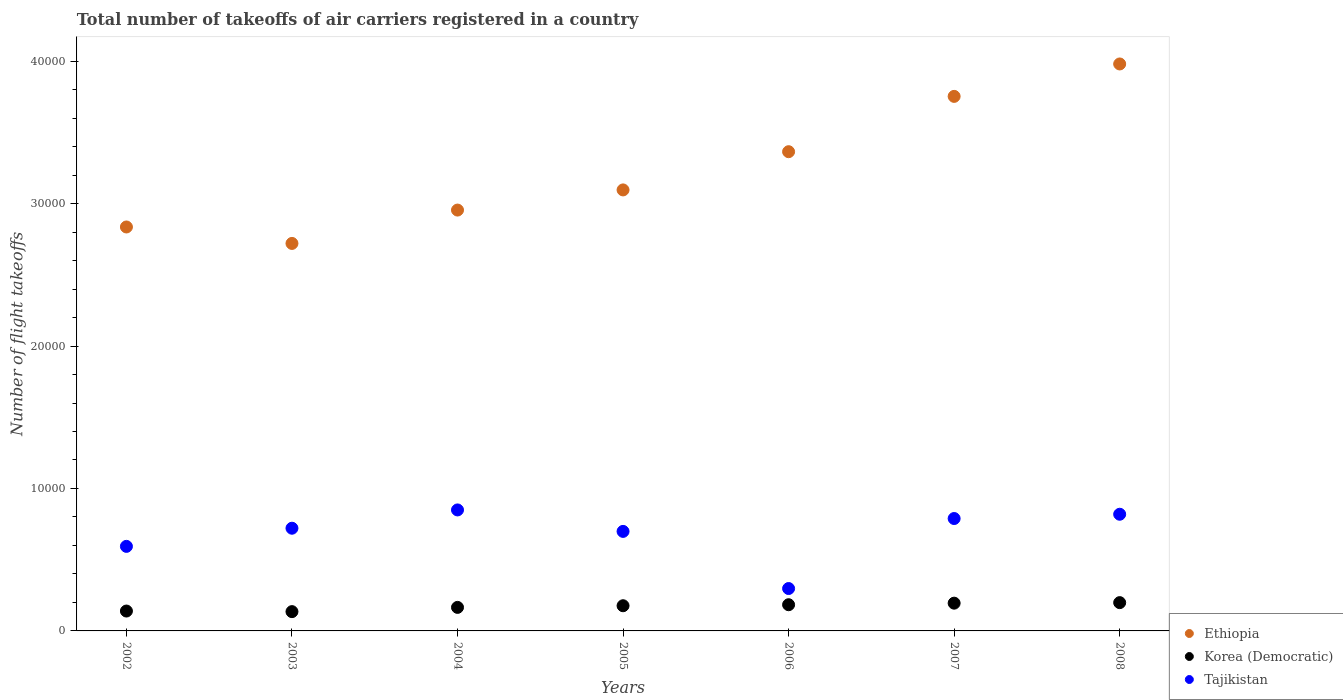How many different coloured dotlines are there?
Ensure brevity in your answer.  3. What is the total number of flight takeoffs in Korea (Democratic) in 2005?
Offer a very short reply. 1768. Across all years, what is the maximum total number of flight takeoffs in Korea (Democratic)?
Make the answer very short. 1986. Across all years, what is the minimum total number of flight takeoffs in Korea (Democratic)?
Provide a short and direct response. 1354. What is the total total number of flight takeoffs in Korea (Democratic) in the graph?
Ensure brevity in your answer.  1.19e+04. What is the difference between the total number of flight takeoffs in Ethiopia in 2002 and that in 2003?
Provide a succinct answer. 1155. What is the difference between the total number of flight takeoffs in Korea (Democratic) in 2004 and the total number of flight takeoffs in Tajikistan in 2007?
Offer a terse response. -6239. What is the average total number of flight takeoffs in Tajikistan per year?
Your response must be concise. 6812.14. In the year 2004, what is the difference between the total number of flight takeoffs in Tajikistan and total number of flight takeoffs in Korea (Democratic)?
Keep it short and to the point. 6842. In how many years, is the total number of flight takeoffs in Korea (Democratic) greater than 20000?
Your answer should be very brief. 0. What is the ratio of the total number of flight takeoffs in Korea (Democratic) in 2002 to that in 2005?
Provide a short and direct response. 0.79. Is the total number of flight takeoffs in Ethiopia in 2002 less than that in 2005?
Your answer should be very brief. Yes. What is the difference between the highest and the second highest total number of flight takeoffs in Tajikistan?
Your answer should be compact. 303. What is the difference between the highest and the lowest total number of flight takeoffs in Korea (Democratic)?
Make the answer very short. 632. Is the sum of the total number of flight takeoffs in Korea (Democratic) in 2006 and 2007 greater than the maximum total number of flight takeoffs in Tajikistan across all years?
Offer a terse response. No. Is it the case that in every year, the sum of the total number of flight takeoffs in Korea (Democratic) and total number of flight takeoffs in Tajikistan  is greater than the total number of flight takeoffs in Ethiopia?
Keep it short and to the point. No. Does the total number of flight takeoffs in Korea (Democratic) monotonically increase over the years?
Make the answer very short. No. Is the total number of flight takeoffs in Ethiopia strictly greater than the total number of flight takeoffs in Tajikistan over the years?
Your answer should be compact. Yes. Is the total number of flight takeoffs in Ethiopia strictly less than the total number of flight takeoffs in Korea (Democratic) over the years?
Provide a short and direct response. No. How many years are there in the graph?
Give a very brief answer. 7. Where does the legend appear in the graph?
Provide a short and direct response. Bottom right. How many legend labels are there?
Offer a terse response. 3. How are the legend labels stacked?
Your answer should be compact. Vertical. What is the title of the graph?
Provide a succinct answer. Total number of takeoffs of air carriers registered in a country. Does "Gabon" appear as one of the legend labels in the graph?
Ensure brevity in your answer.  No. What is the label or title of the Y-axis?
Make the answer very short. Number of flight takeoffs. What is the Number of flight takeoffs of Ethiopia in 2002?
Your response must be concise. 2.84e+04. What is the Number of flight takeoffs in Korea (Democratic) in 2002?
Offer a terse response. 1396. What is the Number of flight takeoffs of Tajikistan in 2002?
Your answer should be compact. 5936. What is the Number of flight takeoffs of Ethiopia in 2003?
Ensure brevity in your answer.  2.72e+04. What is the Number of flight takeoffs in Korea (Democratic) in 2003?
Offer a very short reply. 1354. What is the Number of flight takeoffs in Tajikistan in 2003?
Provide a short and direct response. 7210. What is the Number of flight takeoffs of Ethiopia in 2004?
Your answer should be compact. 2.95e+04. What is the Number of flight takeoffs of Korea (Democratic) in 2004?
Provide a short and direct response. 1652. What is the Number of flight takeoffs of Tajikistan in 2004?
Your response must be concise. 8494. What is the Number of flight takeoffs in Ethiopia in 2005?
Provide a succinct answer. 3.10e+04. What is the Number of flight takeoffs in Korea (Democratic) in 2005?
Offer a terse response. 1768. What is the Number of flight takeoffs of Tajikistan in 2005?
Your answer should be compact. 6987. What is the Number of flight takeoffs in Ethiopia in 2006?
Your answer should be very brief. 3.36e+04. What is the Number of flight takeoffs of Korea (Democratic) in 2006?
Provide a succinct answer. 1839. What is the Number of flight takeoffs of Tajikistan in 2006?
Provide a succinct answer. 2976. What is the Number of flight takeoffs in Ethiopia in 2007?
Make the answer very short. 3.75e+04. What is the Number of flight takeoffs in Korea (Democratic) in 2007?
Keep it short and to the point. 1949. What is the Number of flight takeoffs in Tajikistan in 2007?
Ensure brevity in your answer.  7891. What is the Number of flight takeoffs in Ethiopia in 2008?
Ensure brevity in your answer.  3.98e+04. What is the Number of flight takeoffs in Korea (Democratic) in 2008?
Your answer should be compact. 1986. What is the Number of flight takeoffs in Tajikistan in 2008?
Give a very brief answer. 8191. Across all years, what is the maximum Number of flight takeoffs in Ethiopia?
Offer a very short reply. 3.98e+04. Across all years, what is the maximum Number of flight takeoffs of Korea (Democratic)?
Your response must be concise. 1986. Across all years, what is the maximum Number of flight takeoffs of Tajikistan?
Give a very brief answer. 8494. Across all years, what is the minimum Number of flight takeoffs in Ethiopia?
Your answer should be compact. 2.72e+04. Across all years, what is the minimum Number of flight takeoffs in Korea (Democratic)?
Your answer should be compact. 1354. Across all years, what is the minimum Number of flight takeoffs in Tajikistan?
Your answer should be very brief. 2976. What is the total Number of flight takeoffs in Ethiopia in the graph?
Ensure brevity in your answer.  2.27e+05. What is the total Number of flight takeoffs of Korea (Democratic) in the graph?
Provide a short and direct response. 1.19e+04. What is the total Number of flight takeoffs of Tajikistan in the graph?
Ensure brevity in your answer.  4.77e+04. What is the difference between the Number of flight takeoffs in Ethiopia in 2002 and that in 2003?
Your answer should be very brief. 1155. What is the difference between the Number of flight takeoffs in Korea (Democratic) in 2002 and that in 2003?
Provide a succinct answer. 42. What is the difference between the Number of flight takeoffs in Tajikistan in 2002 and that in 2003?
Offer a very short reply. -1274. What is the difference between the Number of flight takeoffs in Ethiopia in 2002 and that in 2004?
Give a very brief answer. -1187. What is the difference between the Number of flight takeoffs of Korea (Democratic) in 2002 and that in 2004?
Provide a succinct answer. -256. What is the difference between the Number of flight takeoffs in Tajikistan in 2002 and that in 2004?
Your answer should be compact. -2558. What is the difference between the Number of flight takeoffs in Ethiopia in 2002 and that in 2005?
Your answer should be compact. -2602. What is the difference between the Number of flight takeoffs of Korea (Democratic) in 2002 and that in 2005?
Ensure brevity in your answer.  -372. What is the difference between the Number of flight takeoffs of Tajikistan in 2002 and that in 2005?
Make the answer very short. -1051. What is the difference between the Number of flight takeoffs of Ethiopia in 2002 and that in 2006?
Offer a terse response. -5285. What is the difference between the Number of flight takeoffs in Korea (Democratic) in 2002 and that in 2006?
Provide a short and direct response. -443. What is the difference between the Number of flight takeoffs in Tajikistan in 2002 and that in 2006?
Provide a succinct answer. 2960. What is the difference between the Number of flight takeoffs in Ethiopia in 2002 and that in 2007?
Offer a terse response. -9169. What is the difference between the Number of flight takeoffs of Korea (Democratic) in 2002 and that in 2007?
Keep it short and to the point. -553. What is the difference between the Number of flight takeoffs in Tajikistan in 2002 and that in 2007?
Keep it short and to the point. -1955. What is the difference between the Number of flight takeoffs in Ethiopia in 2002 and that in 2008?
Your answer should be very brief. -1.14e+04. What is the difference between the Number of flight takeoffs of Korea (Democratic) in 2002 and that in 2008?
Your answer should be compact. -590. What is the difference between the Number of flight takeoffs of Tajikistan in 2002 and that in 2008?
Ensure brevity in your answer.  -2255. What is the difference between the Number of flight takeoffs in Ethiopia in 2003 and that in 2004?
Give a very brief answer. -2342. What is the difference between the Number of flight takeoffs of Korea (Democratic) in 2003 and that in 2004?
Provide a short and direct response. -298. What is the difference between the Number of flight takeoffs of Tajikistan in 2003 and that in 2004?
Give a very brief answer. -1284. What is the difference between the Number of flight takeoffs of Ethiopia in 2003 and that in 2005?
Offer a very short reply. -3757. What is the difference between the Number of flight takeoffs in Korea (Democratic) in 2003 and that in 2005?
Your answer should be very brief. -414. What is the difference between the Number of flight takeoffs in Tajikistan in 2003 and that in 2005?
Give a very brief answer. 223. What is the difference between the Number of flight takeoffs of Ethiopia in 2003 and that in 2006?
Offer a terse response. -6440. What is the difference between the Number of flight takeoffs of Korea (Democratic) in 2003 and that in 2006?
Offer a terse response. -485. What is the difference between the Number of flight takeoffs in Tajikistan in 2003 and that in 2006?
Provide a short and direct response. 4234. What is the difference between the Number of flight takeoffs of Ethiopia in 2003 and that in 2007?
Provide a short and direct response. -1.03e+04. What is the difference between the Number of flight takeoffs in Korea (Democratic) in 2003 and that in 2007?
Your answer should be compact. -595. What is the difference between the Number of flight takeoffs in Tajikistan in 2003 and that in 2007?
Provide a succinct answer. -681. What is the difference between the Number of flight takeoffs of Ethiopia in 2003 and that in 2008?
Your answer should be compact. -1.26e+04. What is the difference between the Number of flight takeoffs in Korea (Democratic) in 2003 and that in 2008?
Give a very brief answer. -632. What is the difference between the Number of flight takeoffs in Tajikistan in 2003 and that in 2008?
Provide a short and direct response. -981. What is the difference between the Number of flight takeoffs in Ethiopia in 2004 and that in 2005?
Your answer should be very brief. -1415. What is the difference between the Number of flight takeoffs in Korea (Democratic) in 2004 and that in 2005?
Provide a succinct answer. -116. What is the difference between the Number of flight takeoffs in Tajikistan in 2004 and that in 2005?
Give a very brief answer. 1507. What is the difference between the Number of flight takeoffs of Ethiopia in 2004 and that in 2006?
Give a very brief answer. -4098. What is the difference between the Number of flight takeoffs of Korea (Democratic) in 2004 and that in 2006?
Your response must be concise. -187. What is the difference between the Number of flight takeoffs in Tajikistan in 2004 and that in 2006?
Ensure brevity in your answer.  5518. What is the difference between the Number of flight takeoffs in Ethiopia in 2004 and that in 2007?
Provide a short and direct response. -7982. What is the difference between the Number of flight takeoffs in Korea (Democratic) in 2004 and that in 2007?
Your answer should be compact. -297. What is the difference between the Number of flight takeoffs in Tajikistan in 2004 and that in 2007?
Make the answer very short. 603. What is the difference between the Number of flight takeoffs in Ethiopia in 2004 and that in 2008?
Your answer should be very brief. -1.03e+04. What is the difference between the Number of flight takeoffs in Korea (Democratic) in 2004 and that in 2008?
Offer a very short reply. -334. What is the difference between the Number of flight takeoffs in Tajikistan in 2004 and that in 2008?
Your answer should be very brief. 303. What is the difference between the Number of flight takeoffs in Ethiopia in 2005 and that in 2006?
Make the answer very short. -2683. What is the difference between the Number of flight takeoffs in Korea (Democratic) in 2005 and that in 2006?
Keep it short and to the point. -71. What is the difference between the Number of flight takeoffs in Tajikistan in 2005 and that in 2006?
Provide a short and direct response. 4011. What is the difference between the Number of flight takeoffs in Ethiopia in 2005 and that in 2007?
Offer a terse response. -6567. What is the difference between the Number of flight takeoffs of Korea (Democratic) in 2005 and that in 2007?
Make the answer very short. -181. What is the difference between the Number of flight takeoffs of Tajikistan in 2005 and that in 2007?
Keep it short and to the point. -904. What is the difference between the Number of flight takeoffs in Ethiopia in 2005 and that in 2008?
Offer a terse response. -8843. What is the difference between the Number of flight takeoffs in Korea (Democratic) in 2005 and that in 2008?
Your answer should be compact. -218. What is the difference between the Number of flight takeoffs in Tajikistan in 2005 and that in 2008?
Ensure brevity in your answer.  -1204. What is the difference between the Number of flight takeoffs of Ethiopia in 2006 and that in 2007?
Offer a terse response. -3884. What is the difference between the Number of flight takeoffs of Korea (Democratic) in 2006 and that in 2007?
Your answer should be very brief. -110. What is the difference between the Number of flight takeoffs of Tajikistan in 2006 and that in 2007?
Keep it short and to the point. -4915. What is the difference between the Number of flight takeoffs of Ethiopia in 2006 and that in 2008?
Your answer should be compact. -6160. What is the difference between the Number of flight takeoffs of Korea (Democratic) in 2006 and that in 2008?
Provide a short and direct response. -147. What is the difference between the Number of flight takeoffs of Tajikistan in 2006 and that in 2008?
Keep it short and to the point. -5215. What is the difference between the Number of flight takeoffs of Ethiopia in 2007 and that in 2008?
Your answer should be compact. -2276. What is the difference between the Number of flight takeoffs of Korea (Democratic) in 2007 and that in 2008?
Offer a very short reply. -37. What is the difference between the Number of flight takeoffs of Tajikistan in 2007 and that in 2008?
Your answer should be very brief. -300. What is the difference between the Number of flight takeoffs of Ethiopia in 2002 and the Number of flight takeoffs of Korea (Democratic) in 2003?
Your answer should be compact. 2.70e+04. What is the difference between the Number of flight takeoffs in Ethiopia in 2002 and the Number of flight takeoffs in Tajikistan in 2003?
Offer a very short reply. 2.11e+04. What is the difference between the Number of flight takeoffs of Korea (Democratic) in 2002 and the Number of flight takeoffs of Tajikistan in 2003?
Provide a succinct answer. -5814. What is the difference between the Number of flight takeoffs of Ethiopia in 2002 and the Number of flight takeoffs of Korea (Democratic) in 2004?
Provide a succinct answer. 2.67e+04. What is the difference between the Number of flight takeoffs in Ethiopia in 2002 and the Number of flight takeoffs in Tajikistan in 2004?
Your answer should be very brief. 1.99e+04. What is the difference between the Number of flight takeoffs in Korea (Democratic) in 2002 and the Number of flight takeoffs in Tajikistan in 2004?
Your answer should be very brief. -7098. What is the difference between the Number of flight takeoffs in Ethiopia in 2002 and the Number of flight takeoffs in Korea (Democratic) in 2005?
Offer a very short reply. 2.66e+04. What is the difference between the Number of flight takeoffs in Ethiopia in 2002 and the Number of flight takeoffs in Tajikistan in 2005?
Give a very brief answer. 2.14e+04. What is the difference between the Number of flight takeoffs of Korea (Democratic) in 2002 and the Number of flight takeoffs of Tajikistan in 2005?
Your response must be concise. -5591. What is the difference between the Number of flight takeoffs of Ethiopia in 2002 and the Number of flight takeoffs of Korea (Democratic) in 2006?
Your answer should be very brief. 2.65e+04. What is the difference between the Number of flight takeoffs of Ethiopia in 2002 and the Number of flight takeoffs of Tajikistan in 2006?
Your response must be concise. 2.54e+04. What is the difference between the Number of flight takeoffs of Korea (Democratic) in 2002 and the Number of flight takeoffs of Tajikistan in 2006?
Provide a succinct answer. -1580. What is the difference between the Number of flight takeoffs in Ethiopia in 2002 and the Number of flight takeoffs in Korea (Democratic) in 2007?
Offer a terse response. 2.64e+04. What is the difference between the Number of flight takeoffs in Ethiopia in 2002 and the Number of flight takeoffs in Tajikistan in 2007?
Your answer should be very brief. 2.05e+04. What is the difference between the Number of flight takeoffs of Korea (Democratic) in 2002 and the Number of flight takeoffs of Tajikistan in 2007?
Offer a very short reply. -6495. What is the difference between the Number of flight takeoffs in Ethiopia in 2002 and the Number of flight takeoffs in Korea (Democratic) in 2008?
Ensure brevity in your answer.  2.64e+04. What is the difference between the Number of flight takeoffs in Ethiopia in 2002 and the Number of flight takeoffs in Tajikistan in 2008?
Give a very brief answer. 2.02e+04. What is the difference between the Number of flight takeoffs in Korea (Democratic) in 2002 and the Number of flight takeoffs in Tajikistan in 2008?
Ensure brevity in your answer.  -6795. What is the difference between the Number of flight takeoffs in Ethiopia in 2003 and the Number of flight takeoffs in Korea (Democratic) in 2004?
Provide a succinct answer. 2.56e+04. What is the difference between the Number of flight takeoffs in Ethiopia in 2003 and the Number of flight takeoffs in Tajikistan in 2004?
Make the answer very short. 1.87e+04. What is the difference between the Number of flight takeoffs of Korea (Democratic) in 2003 and the Number of flight takeoffs of Tajikistan in 2004?
Offer a terse response. -7140. What is the difference between the Number of flight takeoffs of Ethiopia in 2003 and the Number of flight takeoffs of Korea (Democratic) in 2005?
Offer a very short reply. 2.54e+04. What is the difference between the Number of flight takeoffs in Ethiopia in 2003 and the Number of flight takeoffs in Tajikistan in 2005?
Provide a succinct answer. 2.02e+04. What is the difference between the Number of flight takeoffs in Korea (Democratic) in 2003 and the Number of flight takeoffs in Tajikistan in 2005?
Provide a short and direct response. -5633. What is the difference between the Number of flight takeoffs of Ethiopia in 2003 and the Number of flight takeoffs of Korea (Democratic) in 2006?
Offer a terse response. 2.54e+04. What is the difference between the Number of flight takeoffs of Ethiopia in 2003 and the Number of flight takeoffs of Tajikistan in 2006?
Your answer should be very brief. 2.42e+04. What is the difference between the Number of flight takeoffs of Korea (Democratic) in 2003 and the Number of flight takeoffs of Tajikistan in 2006?
Make the answer very short. -1622. What is the difference between the Number of flight takeoffs of Ethiopia in 2003 and the Number of flight takeoffs of Korea (Democratic) in 2007?
Provide a succinct answer. 2.53e+04. What is the difference between the Number of flight takeoffs of Ethiopia in 2003 and the Number of flight takeoffs of Tajikistan in 2007?
Your response must be concise. 1.93e+04. What is the difference between the Number of flight takeoffs in Korea (Democratic) in 2003 and the Number of flight takeoffs in Tajikistan in 2007?
Your answer should be compact. -6537. What is the difference between the Number of flight takeoffs in Ethiopia in 2003 and the Number of flight takeoffs in Korea (Democratic) in 2008?
Your answer should be very brief. 2.52e+04. What is the difference between the Number of flight takeoffs of Ethiopia in 2003 and the Number of flight takeoffs of Tajikistan in 2008?
Your answer should be compact. 1.90e+04. What is the difference between the Number of flight takeoffs of Korea (Democratic) in 2003 and the Number of flight takeoffs of Tajikistan in 2008?
Ensure brevity in your answer.  -6837. What is the difference between the Number of flight takeoffs of Ethiopia in 2004 and the Number of flight takeoffs of Korea (Democratic) in 2005?
Offer a very short reply. 2.78e+04. What is the difference between the Number of flight takeoffs in Ethiopia in 2004 and the Number of flight takeoffs in Tajikistan in 2005?
Provide a succinct answer. 2.26e+04. What is the difference between the Number of flight takeoffs of Korea (Democratic) in 2004 and the Number of flight takeoffs of Tajikistan in 2005?
Provide a succinct answer. -5335. What is the difference between the Number of flight takeoffs of Ethiopia in 2004 and the Number of flight takeoffs of Korea (Democratic) in 2006?
Keep it short and to the point. 2.77e+04. What is the difference between the Number of flight takeoffs of Ethiopia in 2004 and the Number of flight takeoffs of Tajikistan in 2006?
Make the answer very short. 2.66e+04. What is the difference between the Number of flight takeoffs in Korea (Democratic) in 2004 and the Number of flight takeoffs in Tajikistan in 2006?
Your answer should be compact. -1324. What is the difference between the Number of flight takeoffs of Ethiopia in 2004 and the Number of flight takeoffs of Korea (Democratic) in 2007?
Give a very brief answer. 2.76e+04. What is the difference between the Number of flight takeoffs in Ethiopia in 2004 and the Number of flight takeoffs in Tajikistan in 2007?
Keep it short and to the point. 2.17e+04. What is the difference between the Number of flight takeoffs of Korea (Democratic) in 2004 and the Number of flight takeoffs of Tajikistan in 2007?
Provide a short and direct response. -6239. What is the difference between the Number of flight takeoffs in Ethiopia in 2004 and the Number of flight takeoffs in Korea (Democratic) in 2008?
Your answer should be very brief. 2.76e+04. What is the difference between the Number of flight takeoffs of Ethiopia in 2004 and the Number of flight takeoffs of Tajikistan in 2008?
Provide a short and direct response. 2.14e+04. What is the difference between the Number of flight takeoffs of Korea (Democratic) in 2004 and the Number of flight takeoffs of Tajikistan in 2008?
Your answer should be compact. -6539. What is the difference between the Number of flight takeoffs in Ethiopia in 2005 and the Number of flight takeoffs in Korea (Democratic) in 2006?
Make the answer very short. 2.91e+04. What is the difference between the Number of flight takeoffs in Ethiopia in 2005 and the Number of flight takeoffs in Tajikistan in 2006?
Offer a very short reply. 2.80e+04. What is the difference between the Number of flight takeoffs of Korea (Democratic) in 2005 and the Number of flight takeoffs of Tajikistan in 2006?
Make the answer very short. -1208. What is the difference between the Number of flight takeoffs in Ethiopia in 2005 and the Number of flight takeoffs in Korea (Democratic) in 2007?
Provide a succinct answer. 2.90e+04. What is the difference between the Number of flight takeoffs of Ethiopia in 2005 and the Number of flight takeoffs of Tajikistan in 2007?
Your answer should be compact. 2.31e+04. What is the difference between the Number of flight takeoffs in Korea (Democratic) in 2005 and the Number of flight takeoffs in Tajikistan in 2007?
Ensure brevity in your answer.  -6123. What is the difference between the Number of flight takeoffs in Ethiopia in 2005 and the Number of flight takeoffs in Korea (Democratic) in 2008?
Your answer should be very brief. 2.90e+04. What is the difference between the Number of flight takeoffs in Ethiopia in 2005 and the Number of flight takeoffs in Tajikistan in 2008?
Provide a succinct answer. 2.28e+04. What is the difference between the Number of flight takeoffs in Korea (Democratic) in 2005 and the Number of flight takeoffs in Tajikistan in 2008?
Make the answer very short. -6423. What is the difference between the Number of flight takeoffs in Ethiopia in 2006 and the Number of flight takeoffs in Korea (Democratic) in 2007?
Your answer should be compact. 3.17e+04. What is the difference between the Number of flight takeoffs in Ethiopia in 2006 and the Number of flight takeoffs in Tajikistan in 2007?
Provide a succinct answer. 2.58e+04. What is the difference between the Number of flight takeoffs of Korea (Democratic) in 2006 and the Number of flight takeoffs of Tajikistan in 2007?
Make the answer very short. -6052. What is the difference between the Number of flight takeoffs in Ethiopia in 2006 and the Number of flight takeoffs in Korea (Democratic) in 2008?
Provide a succinct answer. 3.17e+04. What is the difference between the Number of flight takeoffs in Ethiopia in 2006 and the Number of flight takeoffs in Tajikistan in 2008?
Your response must be concise. 2.55e+04. What is the difference between the Number of flight takeoffs of Korea (Democratic) in 2006 and the Number of flight takeoffs of Tajikistan in 2008?
Offer a terse response. -6352. What is the difference between the Number of flight takeoffs of Ethiopia in 2007 and the Number of flight takeoffs of Korea (Democratic) in 2008?
Your answer should be compact. 3.55e+04. What is the difference between the Number of flight takeoffs of Ethiopia in 2007 and the Number of flight takeoffs of Tajikistan in 2008?
Your response must be concise. 2.93e+04. What is the difference between the Number of flight takeoffs in Korea (Democratic) in 2007 and the Number of flight takeoffs in Tajikistan in 2008?
Keep it short and to the point. -6242. What is the average Number of flight takeoffs of Ethiopia per year?
Make the answer very short. 3.24e+04. What is the average Number of flight takeoffs of Korea (Democratic) per year?
Provide a short and direct response. 1706.29. What is the average Number of flight takeoffs of Tajikistan per year?
Offer a very short reply. 6812.14. In the year 2002, what is the difference between the Number of flight takeoffs in Ethiopia and Number of flight takeoffs in Korea (Democratic)?
Give a very brief answer. 2.70e+04. In the year 2002, what is the difference between the Number of flight takeoffs in Ethiopia and Number of flight takeoffs in Tajikistan?
Your answer should be very brief. 2.24e+04. In the year 2002, what is the difference between the Number of flight takeoffs of Korea (Democratic) and Number of flight takeoffs of Tajikistan?
Offer a terse response. -4540. In the year 2003, what is the difference between the Number of flight takeoffs in Ethiopia and Number of flight takeoffs in Korea (Democratic)?
Make the answer very short. 2.58e+04. In the year 2003, what is the difference between the Number of flight takeoffs in Ethiopia and Number of flight takeoffs in Tajikistan?
Your answer should be compact. 2.00e+04. In the year 2003, what is the difference between the Number of flight takeoffs of Korea (Democratic) and Number of flight takeoffs of Tajikistan?
Keep it short and to the point. -5856. In the year 2004, what is the difference between the Number of flight takeoffs in Ethiopia and Number of flight takeoffs in Korea (Democratic)?
Your answer should be compact. 2.79e+04. In the year 2004, what is the difference between the Number of flight takeoffs of Ethiopia and Number of flight takeoffs of Tajikistan?
Provide a succinct answer. 2.11e+04. In the year 2004, what is the difference between the Number of flight takeoffs of Korea (Democratic) and Number of flight takeoffs of Tajikistan?
Offer a very short reply. -6842. In the year 2005, what is the difference between the Number of flight takeoffs of Ethiopia and Number of flight takeoffs of Korea (Democratic)?
Make the answer very short. 2.92e+04. In the year 2005, what is the difference between the Number of flight takeoffs of Ethiopia and Number of flight takeoffs of Tajikistan?
Keep it short and to the point. 2.40e+04. In the year 2005, what is the difference between the Number of flight takeoffs of Korea (Democratic) and Number of flight takeoffs of Tajikistan?
Provide a succinct answer. -5219. In the year 2006, what is the difference between the Number of flight takeoffs of Ethiopia and Number of flight takeoffs of Korea (Democratic)?
Keep it short and to the point. 3.18e+04. In the year 2006, what is the difference between the Number of flight takeoffs in Ethiopia and Number of flight takeoffs in Tajikistan?
Make the answer very short. 3.07e+04. In the year 2006, what is the difference between the Number of flight takeoffs of Korea (Democratic) and Number of flight takeoffs of Tajikistan?
Provide a succinct answer. -1137. In the year 2007, what is the difference between the Number of flight takeoffs of Ethiopia and Number of flight takeoffs of Korea (Democratic)?
Your answer should be compact. 3.56e+04. In the year 2007, what is the difference between the Number of flight takeoffs of Ethiopia and Number of flight takeoffs of Tajikistan?
Your answer should be very brief. 2.96e+04. In the year 2007, what is the difference between the Number of flight takeoffs of Korea (Democratic) and Number of flight takeoffs of Tajikistan?
Make the answer very short. -5942. In the year 2008, what is the difference between the Number of flight takeoffs of Ethiopia and Number of flight takeoffs of Korea (Democratic)?
Provide a succinct answer. 3.78e+04. In the year 2008, what is the difference between the Number of flight takeoffs in Ethiopia and Number of flight takeoffs in Tajikistan?
Your answer should be compact. 3.16e+04. In the year 2008, what is the difference between the Number of flight takeoffs in Korea (Democratic) and Number of flight takeoffs in Tajikistan?
Your answer should be compact. -6205. What is the ratio of the Number of flight takeoffs in Ethiopia in 2002 to that in 2003?
Your answer should be very brief. 1.04. What is the ratio of the Number of flight takeoffs of Korea (Democratic) in 2002 to that in 2003?
Make the answer very short. 1.03. What is the ratio of the Number of flight takeoffs of Tajikistan in 2002 to that in 2003?
Offer a very short reply. 0.82. What is the ratio of the Number of flight takeoffs in Ethiopia in 2002 to that in 2004?
Your answer should be very brief. 0.96. What is the ratio of the Number of flight takeoffs in Korea (Democratic) in 2002 to that in 2004?
Provide a succinct answer. 0.84. What is the ratio of the Number of flight takeoffs in Tajikistan in 2002 to that in 2004?
Keep it short and to the point. 0.7. What is the ratio of the Number of flight takeoffs of Ethiopia in 2002 to that in 2005?
Offer a terse response. 0.92. What is the ratio of the Number of flight takeoffs in Korea (Democratic) in 2002 to that in 2005?
Your answer should be compact. 0.79. What is the ratio of the Number of flight takeoffs of Tajikistan in 2002 to that in 2005?
Offer a terse response. 0.85. What is the ratio of the Number of flight takeoffs of Ethiopia in 2002 to that in 2006?
Keep it short and to the point. 0.84. What is the ratio of the Number of flight takeoffs of Korea (Democratic) in 2002 to that in 2006?
Offer a very short reply. 0.76. What is the ratio of the Number of flight takeoffs of Tajikistan in 2002 to that in 2006?
Provide a short and direct response. 1.99. What is the ratio of the Number of flight takeoffs of Ethiopia in 2002 to that in 2007?
Offer a very short reply. 0.76. What is the ratio of the Number of flight takeoffs in Korea (Democratic) in 2002 to that in 2007?
Your response must be concise. 0.72. What is the ratio of the Number of flight takeoffs of Tajikistan in 2002 to that in 2007?
Provide a succinct answer. 0.75. What is the ratio of the Number of flight takeoffs of Ethiopia in 2002 to that in 2008?
Give a very brief answer. 0.71. What is the ratio of the Number of flight takeoffs of Korea (Democratic) in 2002 to that in 2008?
Make the answer very short. 0.7. What is the ratio of the Number of flight takeoffs in Tajikistan in 2002 to that in 2008?
Give a very brief answer. 0.72. What is the ratio of the Number of flight takeoffs of Ethiopia in 2003 to that in 2004?
Your response must be concise. 0.92. What is the ratio of the Number of flight takeoffs in Korea (Democratic) in 2003 to that in 2004?
Give a very brief answer. 0.82. What is the ratio of the Number of flight takeoffs of Tajikistan in 2003 to that in 2004?
Ensure brevity in your answer.  0.85. What is the ratio of the Number of flight takeoffs in Ethiopia in 2003 to that in 2005?
Ensure brevity in your answer.  0.88. What is the ratio of the Number of flight takeoffs in Korea (Democratic) in 2003 to that in 2005?
Your response must be concise. 0.77. What is the ratio of the Number of flight takeoffs of Tajikistan in 2003 to that in 2005?
Provide a succinct answer. 1.03. What is the ratio of the Number of flight takeoffs in Ethiopia in 2003 to that in 2006?
Your answer should be very brief. 0.81. What is the ratio of the Number of flight takeoffs of Korea (Democratic) in 2003 to that in 2006?
Make the answer very short. 0.74. What is the ratio of the Number of flight takeoffs in Tajikistan in 2003 to that in 2006?
Keep it short and to the point. 2.42. What is the ratio of the Number of flight takeoffs of Ethiopia in 2003 to that in 2007?
Offer a very short reply. 0.72. What is the ratio of the Number of flight takeoffs of Korea (Democratic) in 2003 to that in 2007?
Your response must be concise. 0.69. What is the ratio of the Number of flight takeoffs of Tajikistan in 2003 to that in 2007?
Your response must be concise. 0.91. What is the ratio of the Number of flight takeoffs in Ethiopia in 2003 to that in 2008?
Give a very brief answer. 0.68. What is the ratio of the Number of flight takeoffs of Korea (Democratic) in 2003 to that in 2008?
Provide a short and direct response. 0.68. What is the ratio of the Number of flight takeoffs in Tajikistan in 2003 to that in 2008?
Provide a short and direct response. 0.88. What is the ratio of the Number of flight takeoffs of Ethiopia in 2004 to that in 2005?
Provide a short and direct response. 0.95. What is the ratio of the Number of flight takeoffs of Korea (Democratic) in 2004 to that in 2005?
Offer a terse response. 0.93. What is the ratio of the Number of flight takeoffs in Tajikistan in 2004 to that in 2005?
Offer a very short reply. 1.22. What is the ratio of the Number of flight takeoffs of Ethiopia in 2004 to that in 2006?
Ensure brevity in your answer.  0.88. What is the ratio of the Number of flight takeoffs of Korea (Democratic) in 2004 to that in 2006?
Provide a succinct answer. 0.9. What is the ratio of the Number of flight takeoffs in Tajikistan in 2004 to that in 2006?
Your response must be concise. 2.85. What is the ratio of the Number of flight takeoffs in Ethiopia in 2004 to that in 2007?
Make the answer very short. 0.79. What is the ratio of the Number of flight takeoffs of Korea (Democratic) in 2004 to that in 2007?
Ensure brevity in your answer.  0.85. What is the ratio of the Number of flight takeoffs in Tajikistan in 2004 to that in 2007?
Make the answer very short. 1.08. What is the ratio of the Number of flight takeoffs in Ethiopia in 2004 to that in 2008?
Ensure brevity in your answer.  0.74. What is the ratio of the Number of flight takeoffs of Korea (Democratic) in 2004 to that in 2008?
Keep it short and to the point. 0.83. What is the ratio of the Number of flight takeoffs in Ethiopia in 2005 to that in 2006?
Make the answer very short. 0.92. What is the ratio of the Number of flight takeoffs in Korea (Democratic) in 2005 to that in 2006?
Offer a terse response. 0.96. What is the ratio of the Number of flight takeoffs of Tajikistan in 2005 to that in 2006?
Make the answer very short. 2.35. What is the ratio of the Number of flight takeoffs in Ethiopia in 2005 to that in 2007?
Offer a terse response. 0.82. What is the ratio of the Number of flight takeoffs of Korea (Democratic) in 2005 to that in 2007?
Keep it short and to the point. 0.91. What is the ratio of the Number of flight takeoffs of Tajikistan in 2005 to that in 2007?
Keep it short and to the point. 0.89. What is the ratio of the Number of flight takeoffs of Ethiopia in 2005 to that in 2008?
Ensure brevity in your answer.  0.78. What is the ratio of the Number of flight takeoffs in Korea (Democratic) in 2005 to that in 2008?
Ensure brevity in your answer.  0.89. What is the ratio of the Number of flight takeoffs in Tajikistan in 2005 to that in 2008?
Offer a very short reply. 0.85. What is the ratio of the Number of flight takeoffs of Ethiopia in 2006 to that in 2007?
Provide a succinct answer. 0.9. What is the ratio of the Number of flight takeoffs in Korea (Democratic) in 2006 to that in 2007?
Your answer should be compact. 0.94. What is the ratio of the Number of flight takeoffs of Tajikistan in 2006 to that in 2007?
Provide a succinct answer. 0.38. What is the ratio of the Number of flight takeoffs of Ethiopia in 2006 to that in 2008?
Your answer should be very brief. 0.85. What is the ratio of the Number of flight takeoffs of Korea (Democratic) in 2006 to that in 2008?
Provide a short and direct response. 0.93. What is the ratio of the Number of flight takeoffs in Tajikistan in 2006 to that in 2008?
Provide a short and direct response. 0.36. What is the ratio of the Number of flight takeoffs of Ethiopia in 2007 to that in 2008?
Keep it short and to the point. 0.94. What is the ratio of the Number of flight takeoffs of Korea (Democratic) in 2007 to that in 2008?
Your answer should be very brief. 0.98. What is the ratio of the Number of flight takeoffs in Tajikistan in 2007 to that in 2008?
Your answer should be compact. 0.96. What is the difference between the highest and the second highest Number of flight takeoffs in Ethiopia?
Offer a terse response. 2276. What is the difference between the highest and the second highest Number of flight takeoffs of Tajikistan?
Make the answer very short. 303. What is the difference between the highest and the lowest Number of flight takeoffs of Ethiopia?
Your response must be concise. 1.26e+04. What is the difference between the highest and the lowest Number of flight takeoffs in Korea (Democratic)?
Your answer should be compact. 632. What is the difference between the highest and the lowest Number of flight takeoffs in Tajikistan?
Make the answer very short. 5518. 